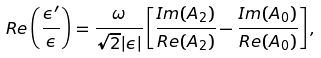<formula> <loc_0><loc_0><loc_500><loc_500>R e \left ( \frac { \epsilon ^ { \prime } } { \epsilon } \right ) = \frac { \omega } { \sqrt { 2 } | \epsilon | } \left [ \frac { I m ( A _ { 2 } ) } { R e ( A _ { 2 } ) } - \frac { I m ( A _ { 0 } ) } { R e ( A _ { 0 } ) } \right ] ,</formula> 